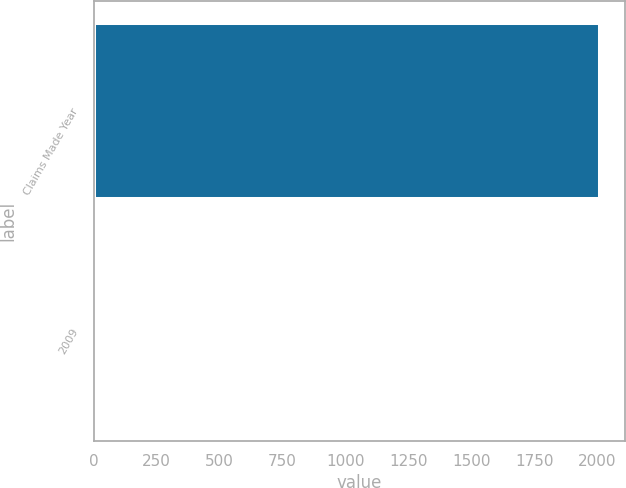Convert chart to OTSL. <chart><loc_0><loc_0><loc_500><loc_500><bar_chart><fcel>Claims Made Year<fcel>2009<nl><fcel>2009<fcel>17<nl></chart> 